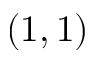<formula> <loc_0><loc_0><loc_500><loc_500>( 1 , 1 )</formula> 